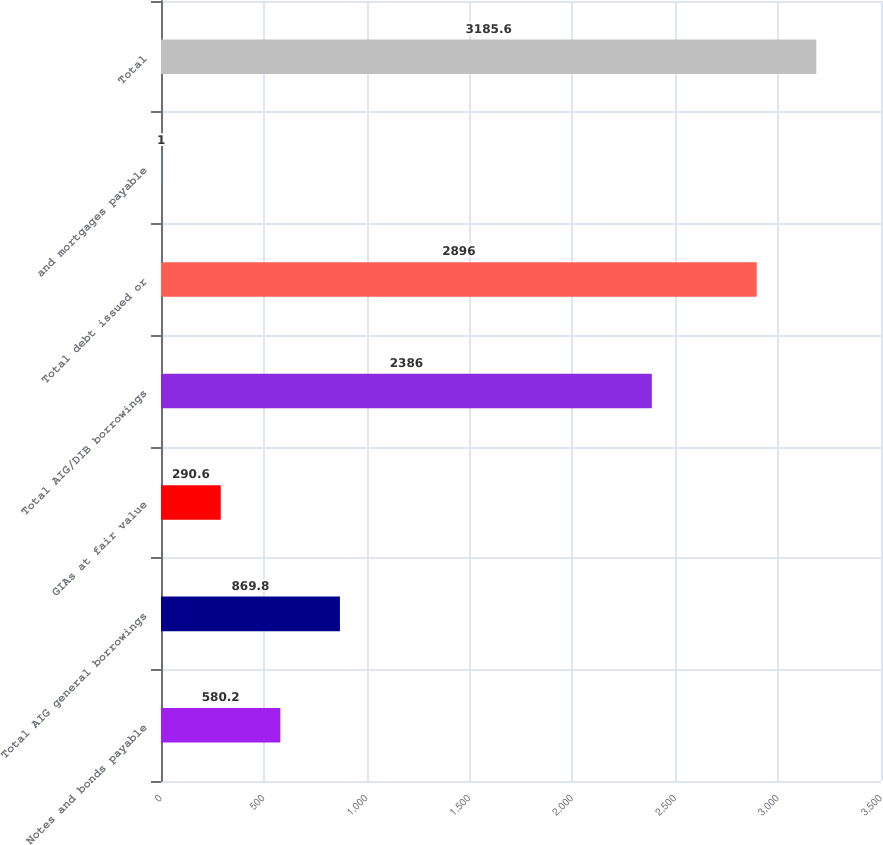Convert chart to OTSL. <chart><loc_0><loc_0><loc_500><loc_500><bar_chart><fcel>Notes and bonds payable<fcel>Total AIG general borrowings<fcel>GIAs at fair value<fcel>Total AIG/DIB borrowings<fcel>Total debt issued or<fcel>and mortgages payable<fcel>Total<nl><fcel>580.2<fcel>869.8<fcel>290.6<fcel>2386<fcel>2896<fcel>1<fcel>3185.6<nl></chart> 